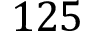Convert formula to latex. <formula><loc_0><loc_0><loc_500><loc_500>1 2 5</formula> 